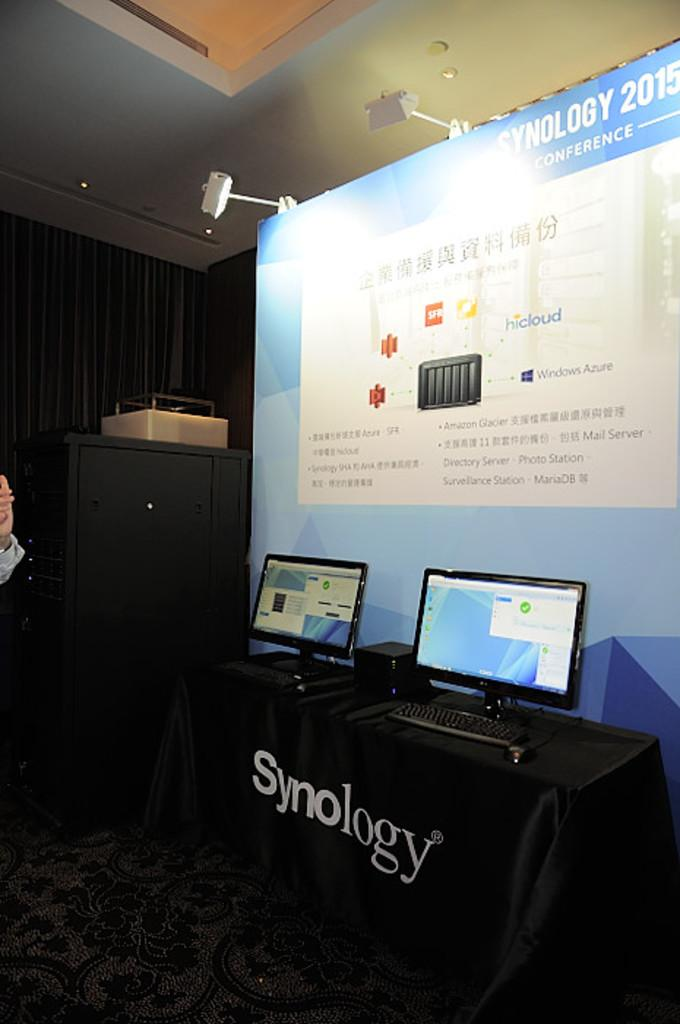<image>
Write a terse but informative summary of the picture. Display for two monitors on top of a table saying Synology. 